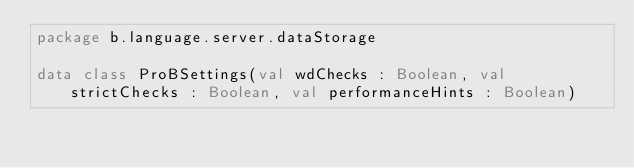Convert code to text. <code><loc_0><loc_0><loc_500><loc_500><_Kotlin_>package b.language.server.dataStorage

data class ProBSettings(val wdChecks : Boolean, val strictChecks : Boolean, val performanceHints : Boolean)</code> 